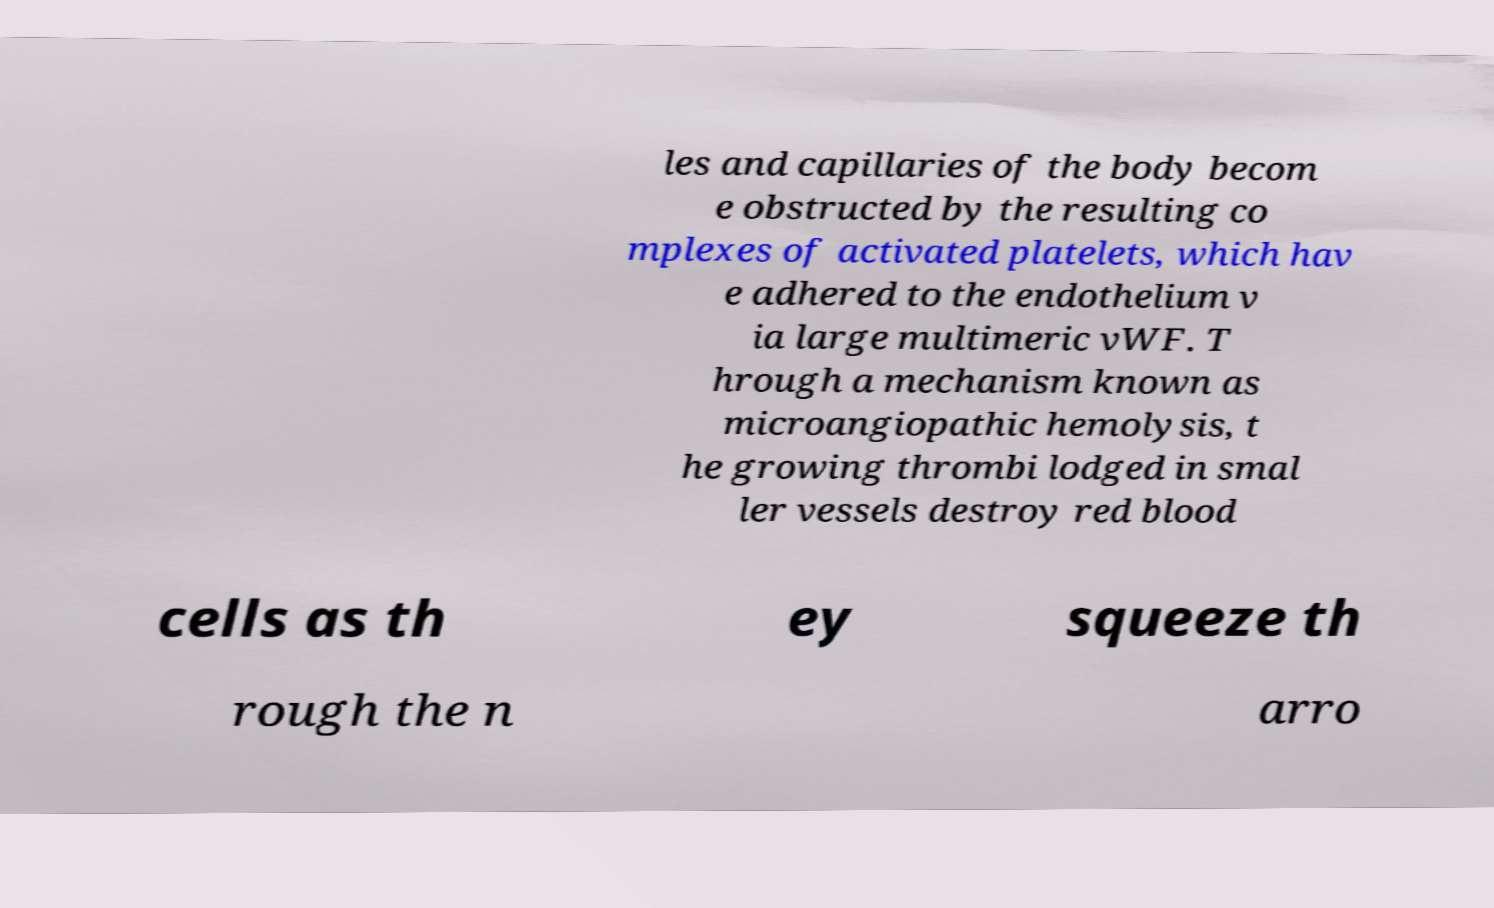Please read and relay the text visible in this image. What does it say? les and capillaries of the body becom e obstructed by the resulting co mplexes of activated platelets, which hav e adhered to the endothelium v ia large multimeric vWF. T hrough a mechanism known as microangiopathic hemolysis, t he growing thrombi lodged in smal ler vessels destroy red blood cells as th ey squeeze th rough the n arro 